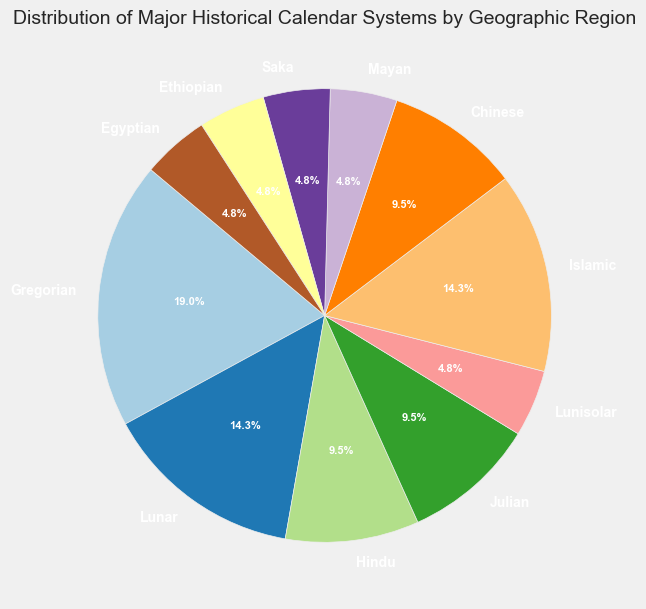Which calendar system represents the highest percentage in the pie chart? The Gregorian calendar has the largest wedge in the pie chart, representing 20%.
Answer: Gregorian Which calendar systems combined represent an equal percentage to the Islamic calendar system? The Islamic calendar system is 15%. By combining the Chinese (10%) and Saka (5%) calendar systems, they sum to 15%, which is equal to the Islamic calendar system's share.
Answer: Chinese and Saka What is the total percentage of calendar systems originating from East Asia? The Lunar calendar (15%) and the Chinese calendar (10%) both originate from East Asia, summing up to 25%.
Answer: 25% Which region has the same percentage of its calendar system as the Julian system? The Julian calendar system is 10%, and the same percentage is seen for the Chinese calendar system in East Asia and the Hindu calendar system in South Asia.
Answer: East Asia (Chinese) and South Asia (Hindu) By how many percentage points does the Gregorian calendar system exceed the combined total of the Mayan and Ethiopian calendars? The Gregorian calendar system is 20%. The combined percentage for the Mayan (5%) and Ethiopian (5%) calendars is 10%. Thus, the Gregorian calendar system exceeds by 10 percentage points.
Answer: 10 percentage points Which two regions combined have the smallest representation in the pie chart? The African Horn (Ethiopian) and Antiquity (Egyptian) each have 5%, summing to a total of 10%, which is the smallest percentage when combined.
Answer: African Horn and Antiquity What is the color used to represent the Lunar calendar in the pie chart? The Lunar calendar is represented by a specific color in the visual, which is provided by the color palette used in the pie chart. Identify the sector color in the pie chart labeled "Lunar".
Answer: [Color specific to the Lunar sector] How much more does the Middle East's Gregorian calendar coverage surpass its Islamic calendar? Gregorian calendar (20%) surpasses the Islamic calendar (15%) by 5%. Subtract 15% from 20% to find the difference.
Answer: 5% 